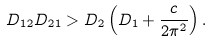Convert formula to latex. <formula><loc_0><loc_0><loc_500><loc_500>D _ { 1 2 } D _ { 2 1 } > D _ { 2 } \left ( D _ { 1 } + \frac { c } { 2 \pi ^ { 2 } } \right ) .</formula> 